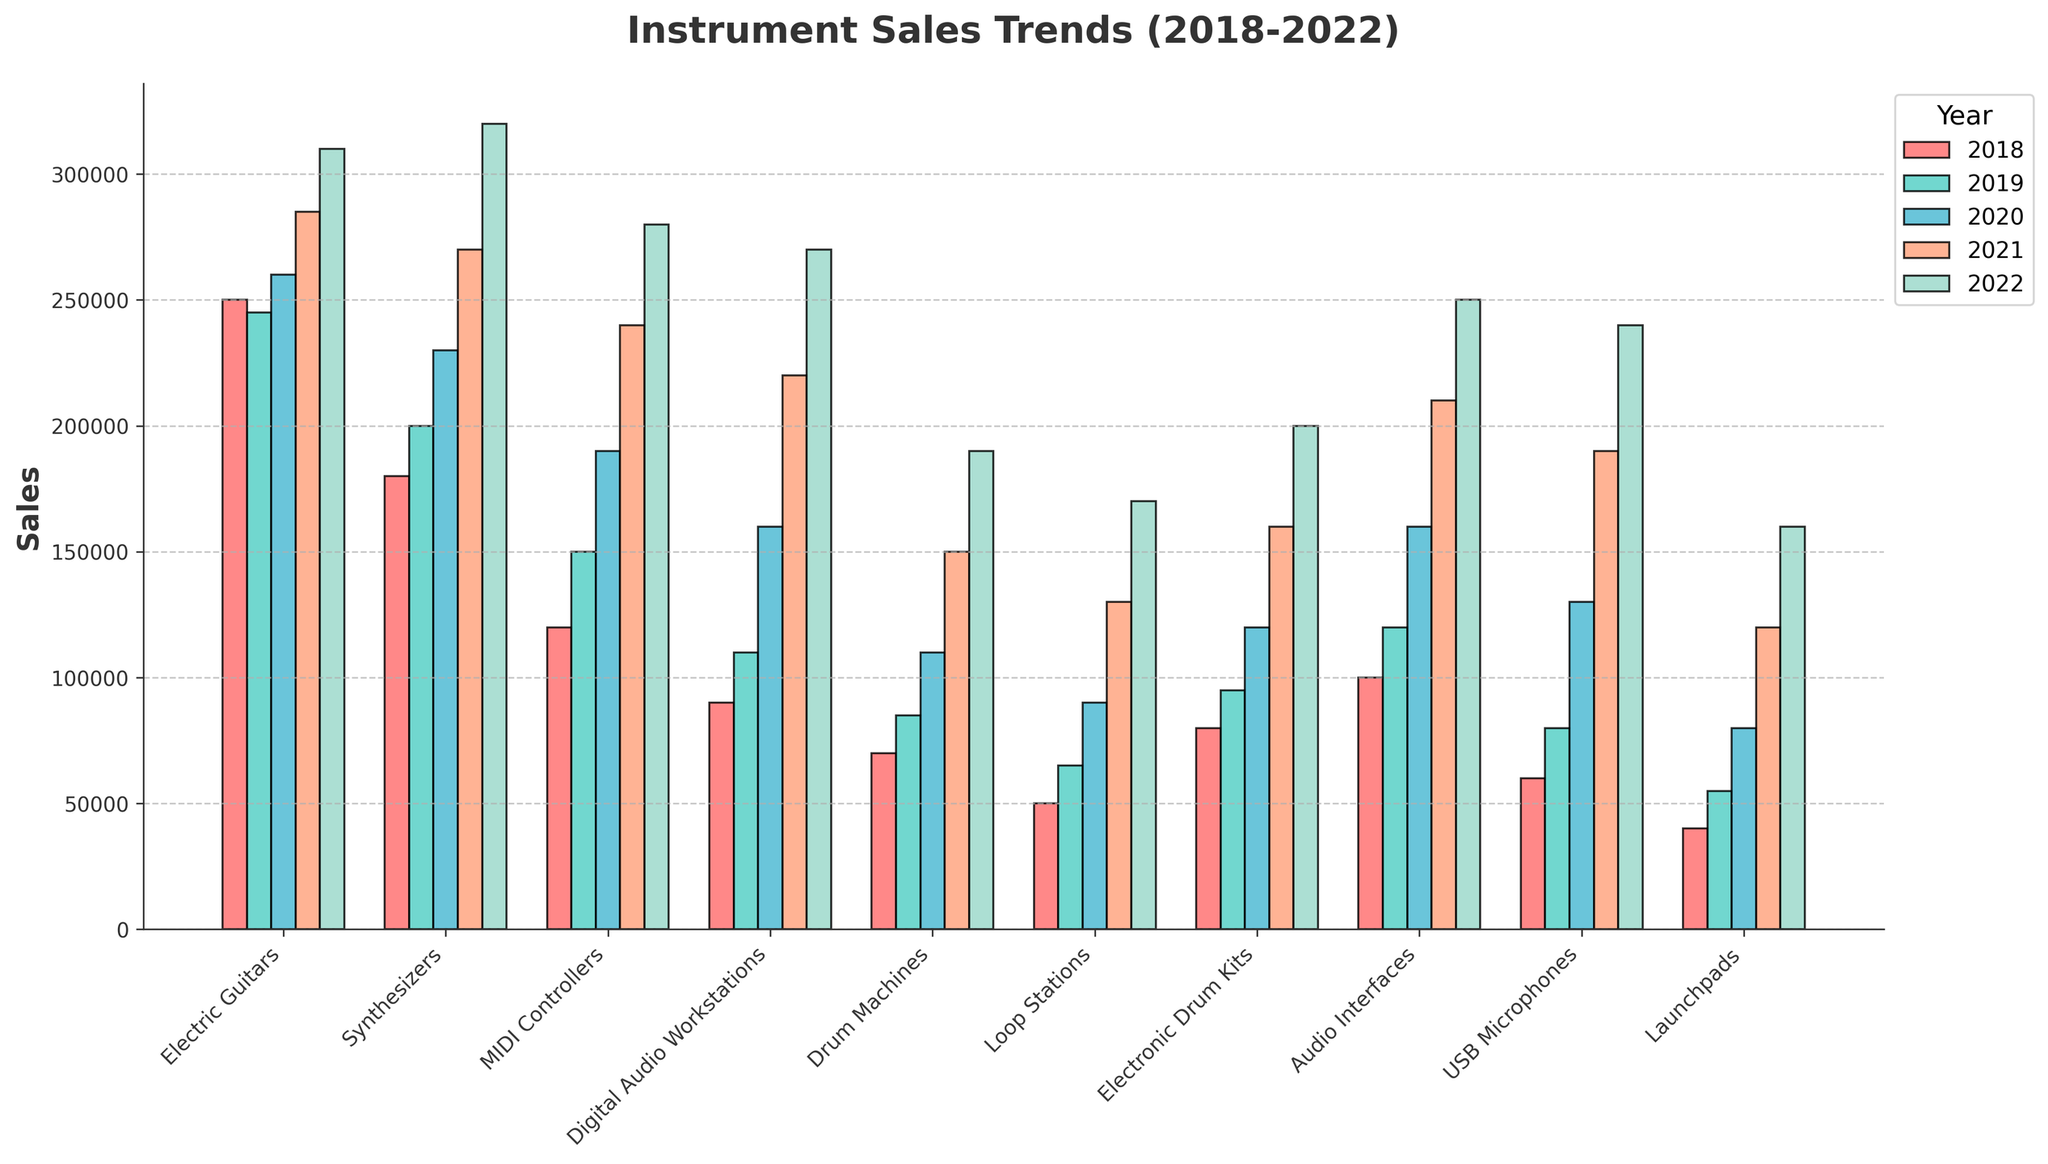What's the total sales of Synthesizers over the 5 years? To find the total sales of Synthesizers from 2018 to 2022, we need to sum the yearly sales: 180,000 (2018) + 200,000 (2019) + 230,000 (2020) + 270,000 (2021) + 320,000 (2022). This calculation gives us 1,200,000 units sold over the 5 years.
Answer: 1,200,000 Which instrument type had the highest sales in 2022? By comparing the heights of the bars corresponding to 2022, we see that Synthesizers have the highest bar. Therefore, Synthesizers had the highest sales in 2022.
Answer: Synthesizers How much did the sales of Drum Machines increase from 2018 to 2022? To find the increase, subtract the 2018 sales from the 2022 sales: 190,000 (2022) - 70,000 (2018). This calculation shows an increase of 120,000 units.
Answer: 120,000 What is the average yearly sales of Electric Guitars from 2018 to 2022? To find the average yearly sales, sum the annual sales and divide by the number of years. The total is 250,000 + 245,000 + 260,000 + 285,000 + 310,000 = 1,350,000. Dividing by 5 gives an average of 270,000 units per year.
Answer: 270,000 Which instrument type had the lowest sales in 2020? By checking the bars for 2020, we see that Launchpads have the shortest bar. Therefore, Launchpads had the lowest sales in 2020.
Answer: Launchpads Is the sales trend for USB Microphones increasing, decreasing, or stable over the 5 years? By observing the increasing heights of the bars from 2018 to 2022, it is clear that the sales trend for USB Microphones is increasing.
Answer: Increasing What is the difference in sales between Audio Interfaces and MIDI Controllers in 2021? Subtract the sales of MIDI Controllers from Audio Interfaces in 2021: 210,000 (Audio Interfaces) - 240,000 (MIDI Controllers). This calculation shows a difference of -30,000 units, indicating MIDI Controllers sold more.
Answer: 30,000 (MIDI Controllers sold more) Which year did Loop Stations see the largest growth in sales compared to the previous year? By comparing the differences year-over-year for Loop Stations:
2019-2018: 65,000 - 50,000 = 15,000
2020-2019: 90,000 - 65,000 = 25,000
2021-2020: 130,000 - 90,000 = 40,000
2022-2021: 170,000 - 130,000 = 40,000
The largest growth was 40,000 units, which occurred in both 2021 and 2022.
Answer: 2021 and 2022 What was the total sales for all instrument types combined in 2020? To find the total, sum all the sales figures for 2020:
Electric Guitars: 260,000
Synthesizers: 230,000
MIDI Controllers: 190,000
Digital Audio Workstations: 160,000
Drum Machines: 110,000
Loop Stations: 90,000
Electronic Drum Kits: 120,000
Audio Interfaces: 160,000
USB Microphones: 130,000
Launchpads: 80,000
Total: 1,530,000 units
Answer: 1,530,000 